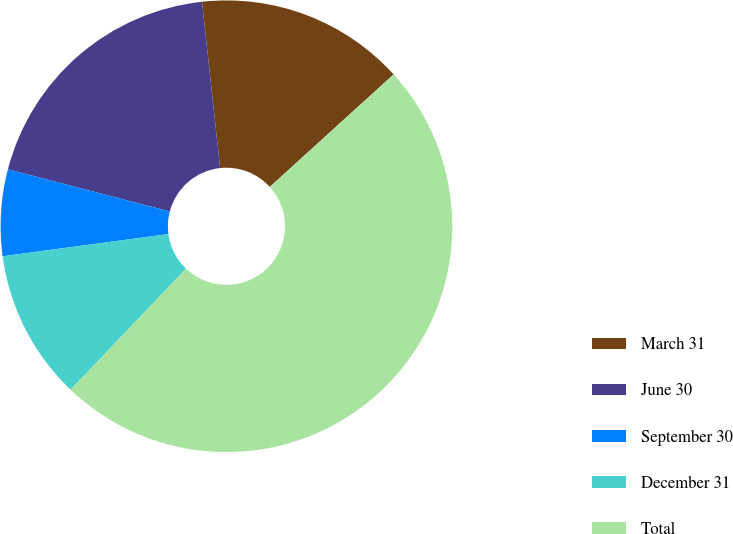<chart> <loc_0><loc_0><loc_500><loc_500><pie_chart><fcel>March 31<fcel>June 30<fcel>September 30<fcel>December 31<fcel>Total<nl><fcel>14.99%<fcel>19.22%<fcel>6.18%<fcel>10.76%<fcel>48.86%<nl></chart> 